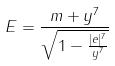<formula> <loc_0><loc_0><loc_500><loc_500>E = \frac { m + y ^ { 7 } } { \sqrt { 1 - \frac { | e | ^ { 7 } } { y ^ { 7 } } } }</formula> 